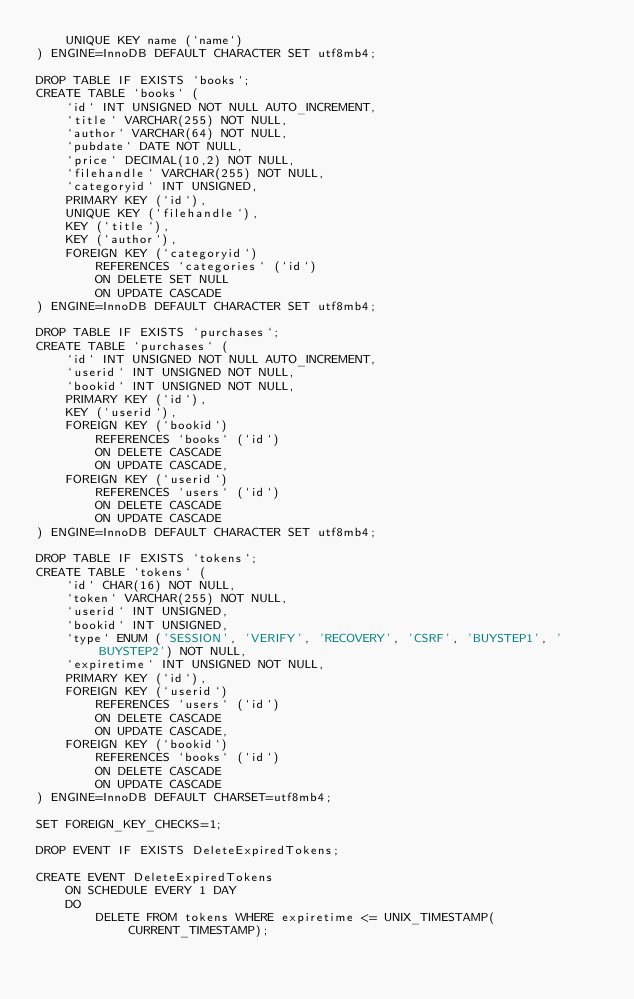<code> <loc_0><loc_0><loc_500><loc_500><_SQL_>	UNIQUE KEY name (`name`)
) ENGINE=InnoDB DEFAULT CHARACTER SET utf8mb4;

DROP TABLE IF EXISTS `books`;
CREATE TABLE `books` (
	`id` INT UNSIGNED NOT NULL AUTO_INCREMENT,
	`title` VARCHAR(255) NOT NULL,
	`author` VARCHAR(64) NOT NULL,
	`pubdate` DATE NOT NULL,
	`price` DECIMAL(10,2) NOT NULL,
	`filehandle` VARCHAR(255) NOT NULL,
	`categoryid` INT UNSIGNED,
	PRIMARY KEY (`id`),
	UNIQUE KEY (`filehandle`),
	KEY (`title`),
	KEY (`author`),
	FOREIGN KEY (`categoryid`)
		REFERENCES `categories` (`id`)
		ON DELETE SET NULL
		ON UPDATE CASCADE
) ENGINE=InnoDB DEFAULT CHARACTER SET utf8mb4;

DROP TABLE IF EXISTS `purchases`;
CREATE TABLE `purchases` (
	`id` INT UNSIGNED NOT NULL AUTO_INCREMENT,
	`userid` INT UNSIGNED NOT NULL,
	`bookid` INT UNSIGNED NOT NULL,
	PRIMARY KEY (`id`),
	KEY (`userid`),
	FOREIGN KEY (`bookid`)
		REFERENCES `books` (`id`)
		ON DELETE CASCADE
		ON UPDATE CASCADE,
	FOREIGN KEY (`userid`)
		REFERENCES `users` (`id`)
		ON DELETE CASCADE
		ON UPDATE CASCADE
) ENGINE=InnoDB DEFAULT CHARACTER SET utf8mb4;

DROP TABLE IF EXISTS `tokens`;
CREATE TABLE `tokens` (
	`id` CHAR(16) NOT NULL,
	`token` VARCHAR(255) NOT NULL,
	`userid` INT UNSIGNED,
	`bookid` INT UNSIGNED,
	`type` ENUM ('SESSION', 'VERIFY', 'RECOVERY', 'CSRF', 'BUYSTEP1', 'BUYSTEP2') NOT NULL,
	`expiretime` INT UNSIGNED NOT NULL,
	PRIMARY KEY (`id`),
	FOREIGN KEY (`userid`)
		REFERENCES `users` (`id`)
		ON DELETE CASCADE
		ON UPDATE CASCADE,
	FOREIGN KEY (`bookid`)
		REFERENCES `books` (`id`)
		ON DELETE CASCADE
		ON UPDATE CASCADE
) ENGINE=InnoDB DEFAULT CHARSET=utf8mb4;

SET FOREIGN_KEY_CHECKS=1;

DROP EVENT IF EXISTS DeleteExpiredTokens;

CREATE EVENT DeleteExpiredTokens
	ON SCHEDULE EVERY 1 DAY
	DO
		DELETE FROM tokens WHERE expiretime <= UNIX_TIMESTAMP(CURRENT_TIMESTAMP);
</code> 